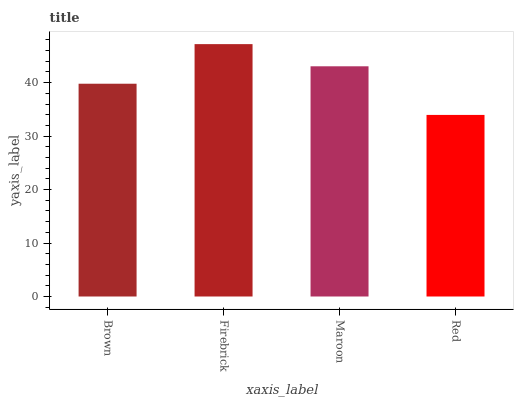Is Red the minimum?
Answer yes or no. Yes. Is Firebrick the maximum?
Answer yes or no. Yes. Is Maroon the minimum?
Answer yes or no. No. Is Maroon the maximum?
Answer yes or no. No. Is Firebrick greater than Maroon?
Answer yes or no. Yes. Is Maroon less than Firebrick?
Answer yes or no. Yes. Is Maroon greater than Firebrick?
Answer yes or no. No. Is Firebrick less than Maroon?
Answer yes or no. No. Is Maroon the high median?
Answer yes or no. Yes. Is Brown the low median?
Answer yes or no. Yes. Is Brown the high median?
Answer yes or no. No. Is Red the low median?
Answer yes or no. No. 